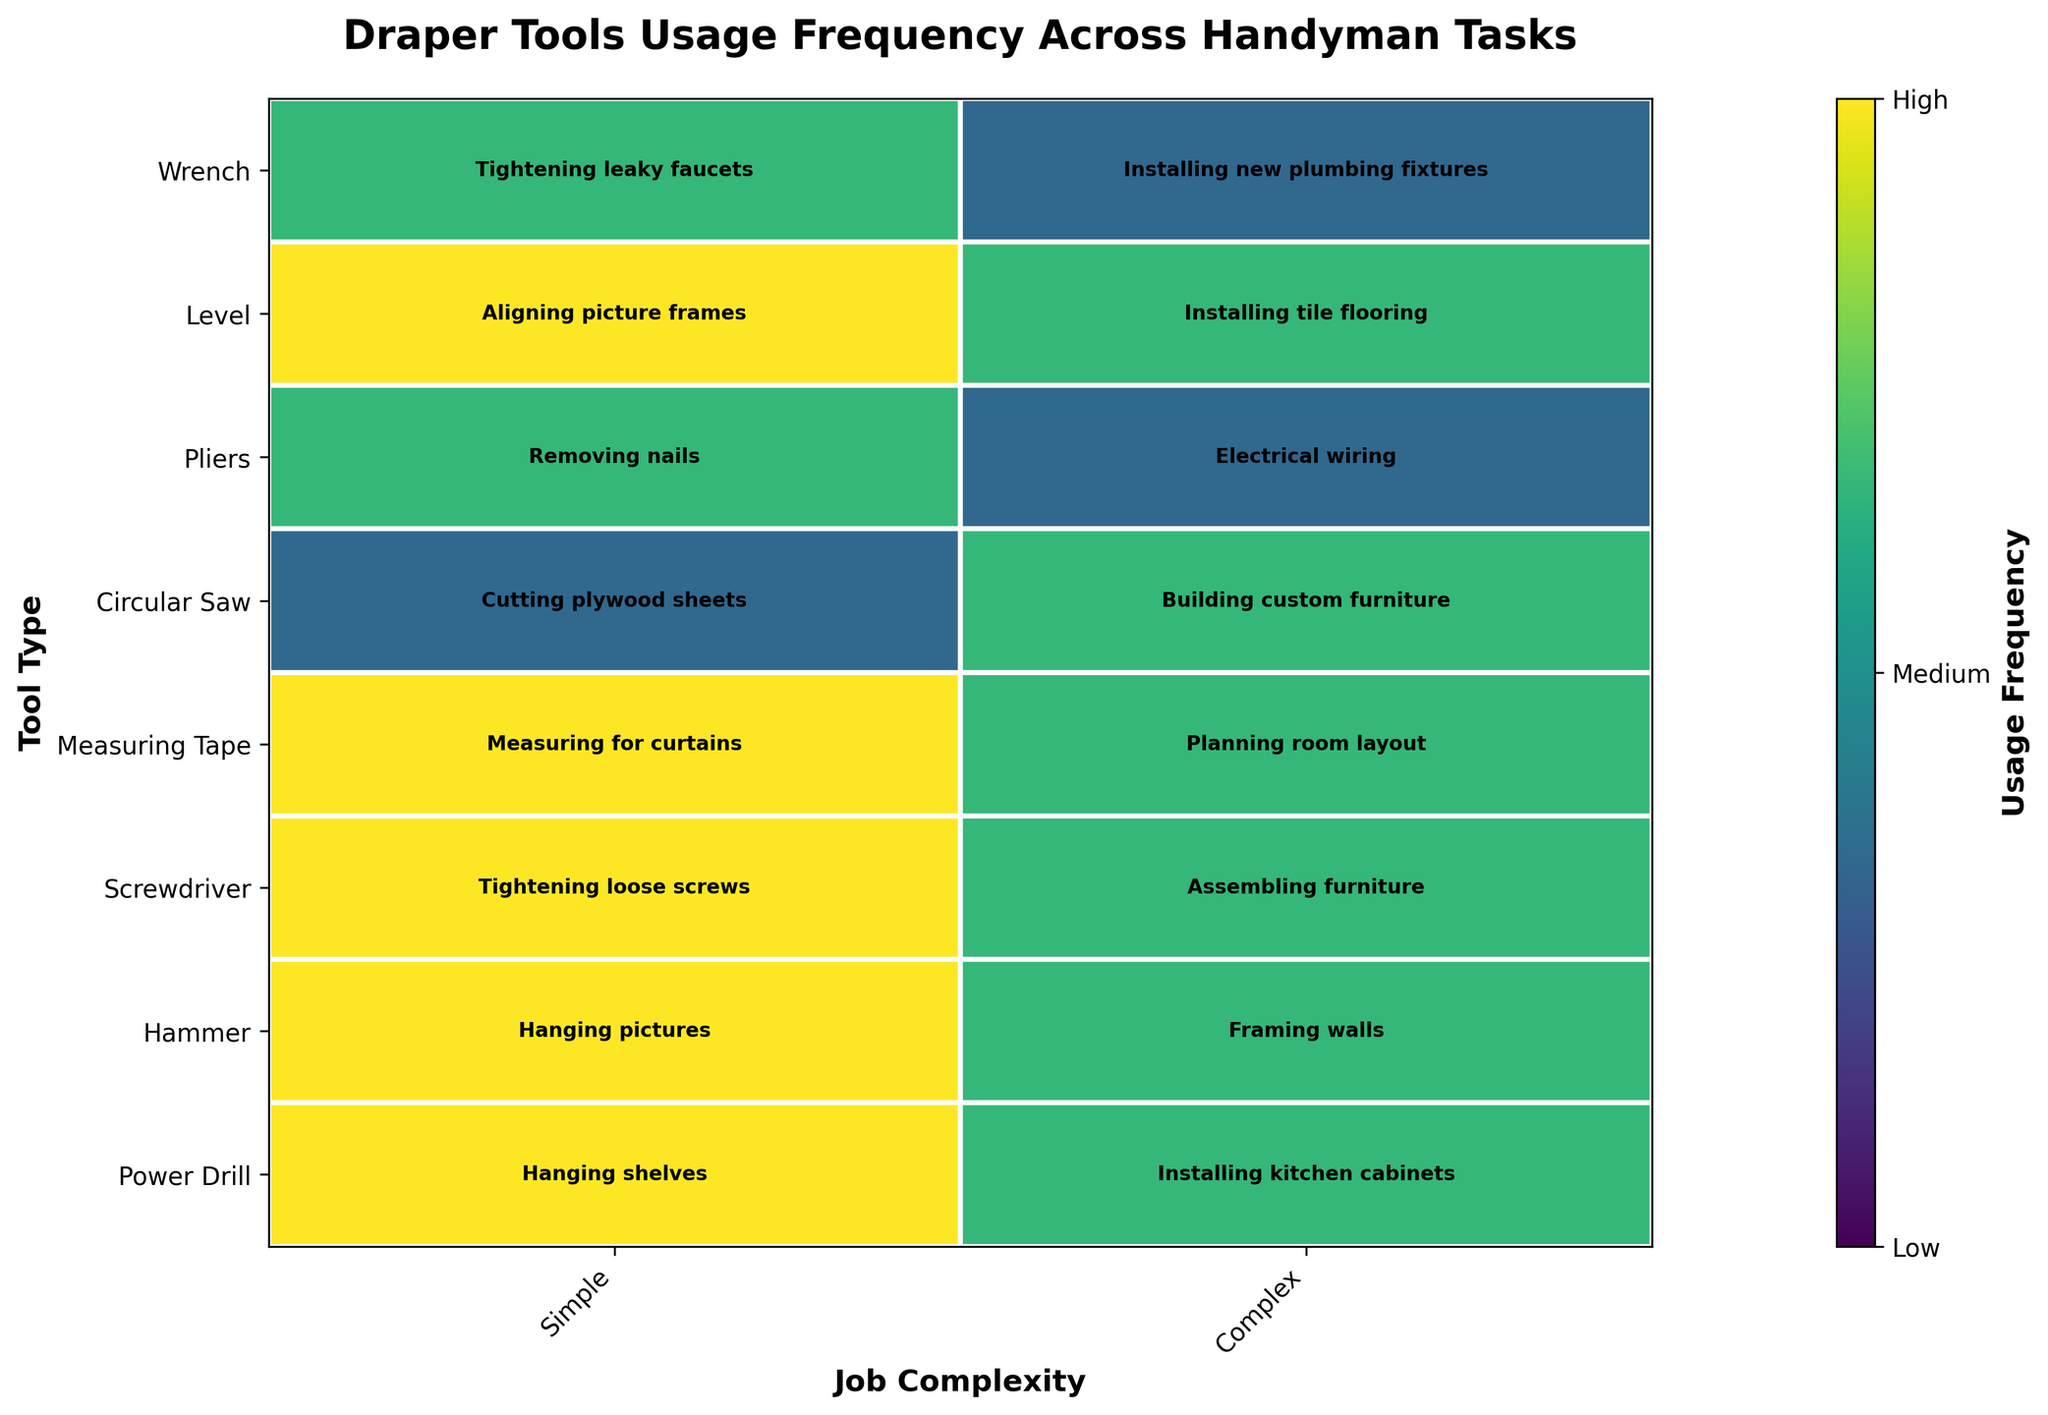What's the most frequently used tool for simple tasks? For simple tasks, we look at the frequency for each tool type under "Simple". The 'Power Drill', 'Hammer', 'Screwdriver', 'Measuring Tape', and 'Level' all show 'High' usage. Since 'High' is the maximum frequency, these tools are equally most frequently used.
Answer: Power Drill, Hammer, Screwdriver, Measuring Tape, Level Which tool is used the least for complex tasks? For complex tasks, we check the frequency for each tool type under "Complex". 'Pliers' and 'Wrench' show 'Low' usage frequency, which is the minimum.
Answer: Pliers, Wrench Compare the usage frequency of the 'Power Drill' for simple and complex tasks. For simple tasks, 'Power Drill' has a 'High' frequency. For complex tasks, it exhibits a 'Medium' frequency. By comparing 'High' and 'Medium', we can see the 'Power Drill' is used more frequently for simple tasks.
Answer: More frequent for simple tasks How many unique tasks are shown for complex jobs? Each rectangle represents a unique task in the mosaic plot. For complex jobs, each tool type has its own task rectangle. Counting these rectangles, we have tasks for 'Power Drill', 'Hammer', 'Screwdriver', 'Measuring Tape', 'Circular Saw', 'Pliers', 'Level', 'Wrench'. So, there are 8 unique tasks for complex jobs.
Answer: 8 What's the ratio of high usage to low usage for simple tasks? In the simple tasks section, there are 'High' for 'Power Drill', 'Hammer', 'Screwdriver', 'Measuring Tape', and 'Level' (5 times), 'Medium' for 'Pliers' and 'Wrench' (2 times), and 'Low' for 'Circular Saw' (1 time). The ratio of 'High' to 'Low' usage for simple tasks is thus 5:1.
Answer: 5:1 What tool and job complexity combination is associated with 'Installing kitchen cabinets'? By examining the plot or task text, we see 'Installing kitchen cabinets' is found under 'Power Drill' and 'Complex' job complexity.
Answer: Power Drill and Complex Is 'Framing walls' a highly frequent task? Looking at the plot, 'Framing walls' is under 'Hammer' and 'Complex'. The frequency shown is 'Medium', not 'High'.
Answer: No Which tool is used more frequently for 'Electrical wiring' than 'Removing nails'? 'Removing nails' is under 'Pliers' in the simple tasks and has a 'Medium' frequency. 'Electrical wiring' for complex tasks, also under 'Pliers', shows a 'Low' frequency. Hence, 'Removing nails' is more frequent. No tool is used more frequently for 'Electrical wiring' compared to 'Removing nails'.
Answer: None 